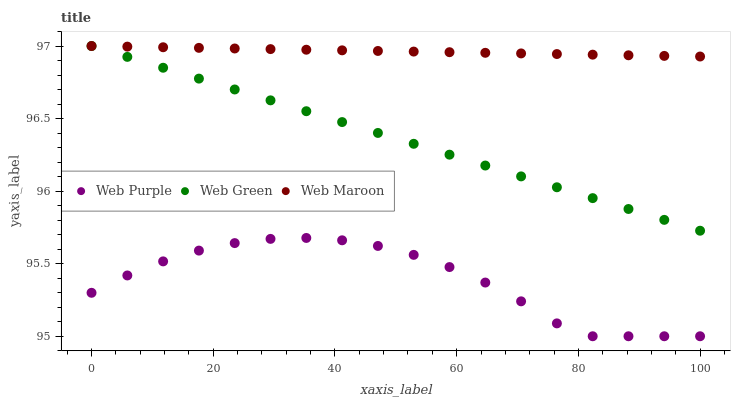Does Web Purple have the minimum area under the curve?
Answer yes or no. Yes. Does Web Maroon have the maximum area under the curve?
Answer yes or no. Yes. Does Web Green have the minimum area under the curve?
Answer yes or no. No. Does Web Green have the maximum area under the curve?
Answer yes or no. No. Is Web Maroon the smoothest?
Answer yes or no. Yes. Is Web Purple the roughest?
Answer yes or no. Yes. Is Web Green the smoothest?
Answer yes or no. No. Is Web Green the roughest?
Answer yes or no. No. Does Web Purple have the lowest value?
Answer yes or no. Yes. Does Web Green have the lowest value?
Answer yes or no. No. Does Web Green have the highest value?
Answer yes or no. Yes. Is Web Purple less than Web Maroon?
Answer yes or no. Yes. Is Web Maroon greater than Web Purple?
Answer yes or no. Yes. Does Web Green intersect Web Maroon?
Answer yes or no. Yes. Is Web Green less than Web Maroon?
Answer yes or no. No. Is Web Green greater than Web Maroon?
Answer yes or no. No. Does Web Purple intersect Web Maroon?
Answer yes or no. No. 